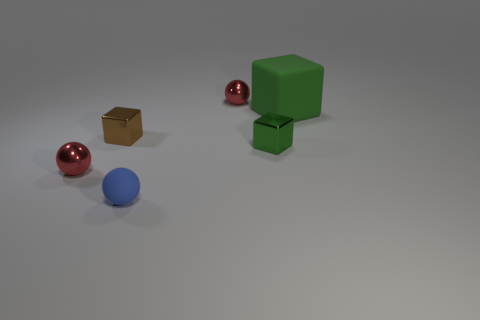Does the large cube have the same material as the blue ball?
Your answer should be compact. Yes. How many large green cubes are the same material as the large green thing?
Give a very brief answer. 0. The tiny cube that is the same material as the tiny green object is what color?
Offer a very short reply. Brown. What shape is the big matte object?
Give a very brief answer. Cube. What is the material of the small red object behind the green matte object?
Provide a succinct answer. Metal. Are there any rubber balls that have the same color as the large matte cube?
Keep it short and to the point. No. There is a green object that is the same size as the blue ball; what is its shape?
Offer a very short reply. Cube. What color is the small metal ball behind the green rubber block?
Your response must be concise. Red. There is a shiny ball in front of the large green block; are there any small red metallic objects that are in front of it?
Keep it short and to the point. No. What number of objects are tiny brown metal blocks to the left of the rubber sphere or green blocks?
Ensure brevity in your answer.  3. 